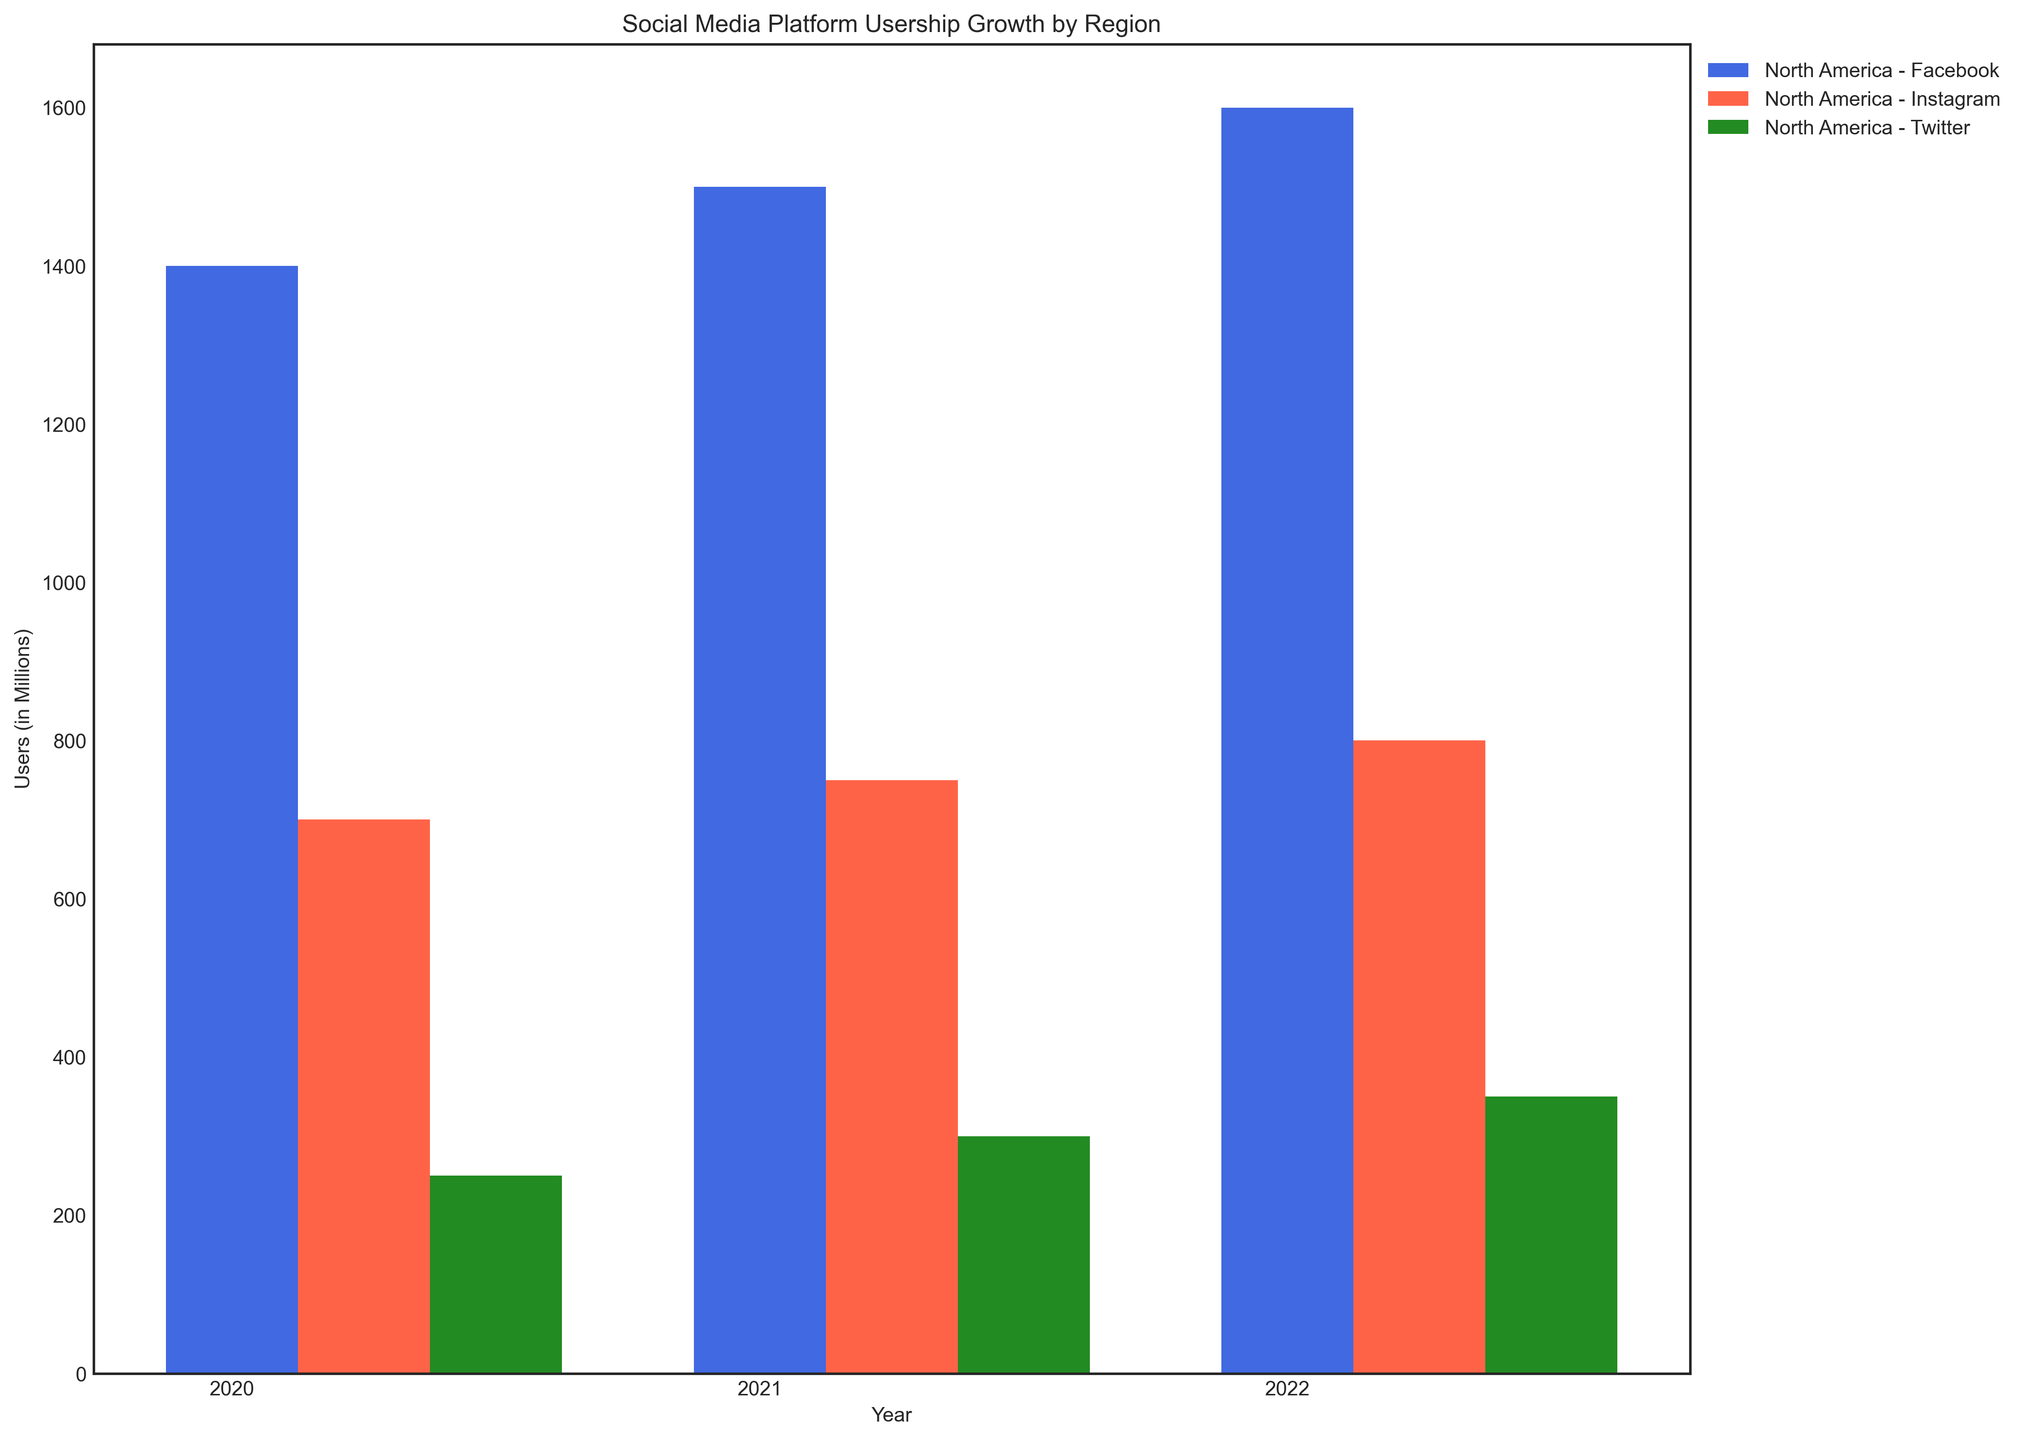Which region had the highest user growth for Facebook from 2020 to 2022? Check the heights of the bars labeled 'Facebook' from 2020 to 2022 for each region. Asia had the greatest increase, going from 1400 million in 2020 to 1600 million in 2022.
Answer: Asia Which region had the least users for Instagram across all years? Compare the heights of the bars labeled 'Instagram' across all regions and years. Africa consistently has the lowest bars, indicating the least users.
Answer: Africa How many total users did Twitter have in North America in 2021 and 2022 combined? Check the heights of the bars labeled 'Twitter' for North America in 2021 (75 million) and 2022 (80 million). Sum these two values: 75 + 80 = 155 million.
Answer: 155 million Which platform showed the most consistent growth in Europe from 2020 to 2022? Compare the heights of bars for each platform across 2020, 2021, and 2022 in Europe. Facebook and Instagram both show linear growth, but Facebook slightly outpaces Instagram.
Answer: Facebook What's the difference in Instagram users between North America and South America in 2022? Check the heights of bars labeled 'Instagram' in 2022 for both North America (150 million) and South America (120 million). Calculate the difference: 150 - 120 = 30 million.
Answer: 30 million Which region gained the most Twitter users from 2020 to 2022? Compare the height difference of bars labeled 'Twitter' from 2020 to 2022 for all regions. Asia saw the most significant increase, going from 250 million to 350 million users.
Answer: Asia What is the average number of Facebook users across all regions in 2022? Check the number of Facebook users for each region in 2022: North America (210 million), Europe (300 million), Asia (1600 million), South America (140 million), Africa (140 million). Sum them and divide by the number of regions: (210 + 300 + 1600 + 140 + 140) / 5 = 478 million.
Answer: 478 million 